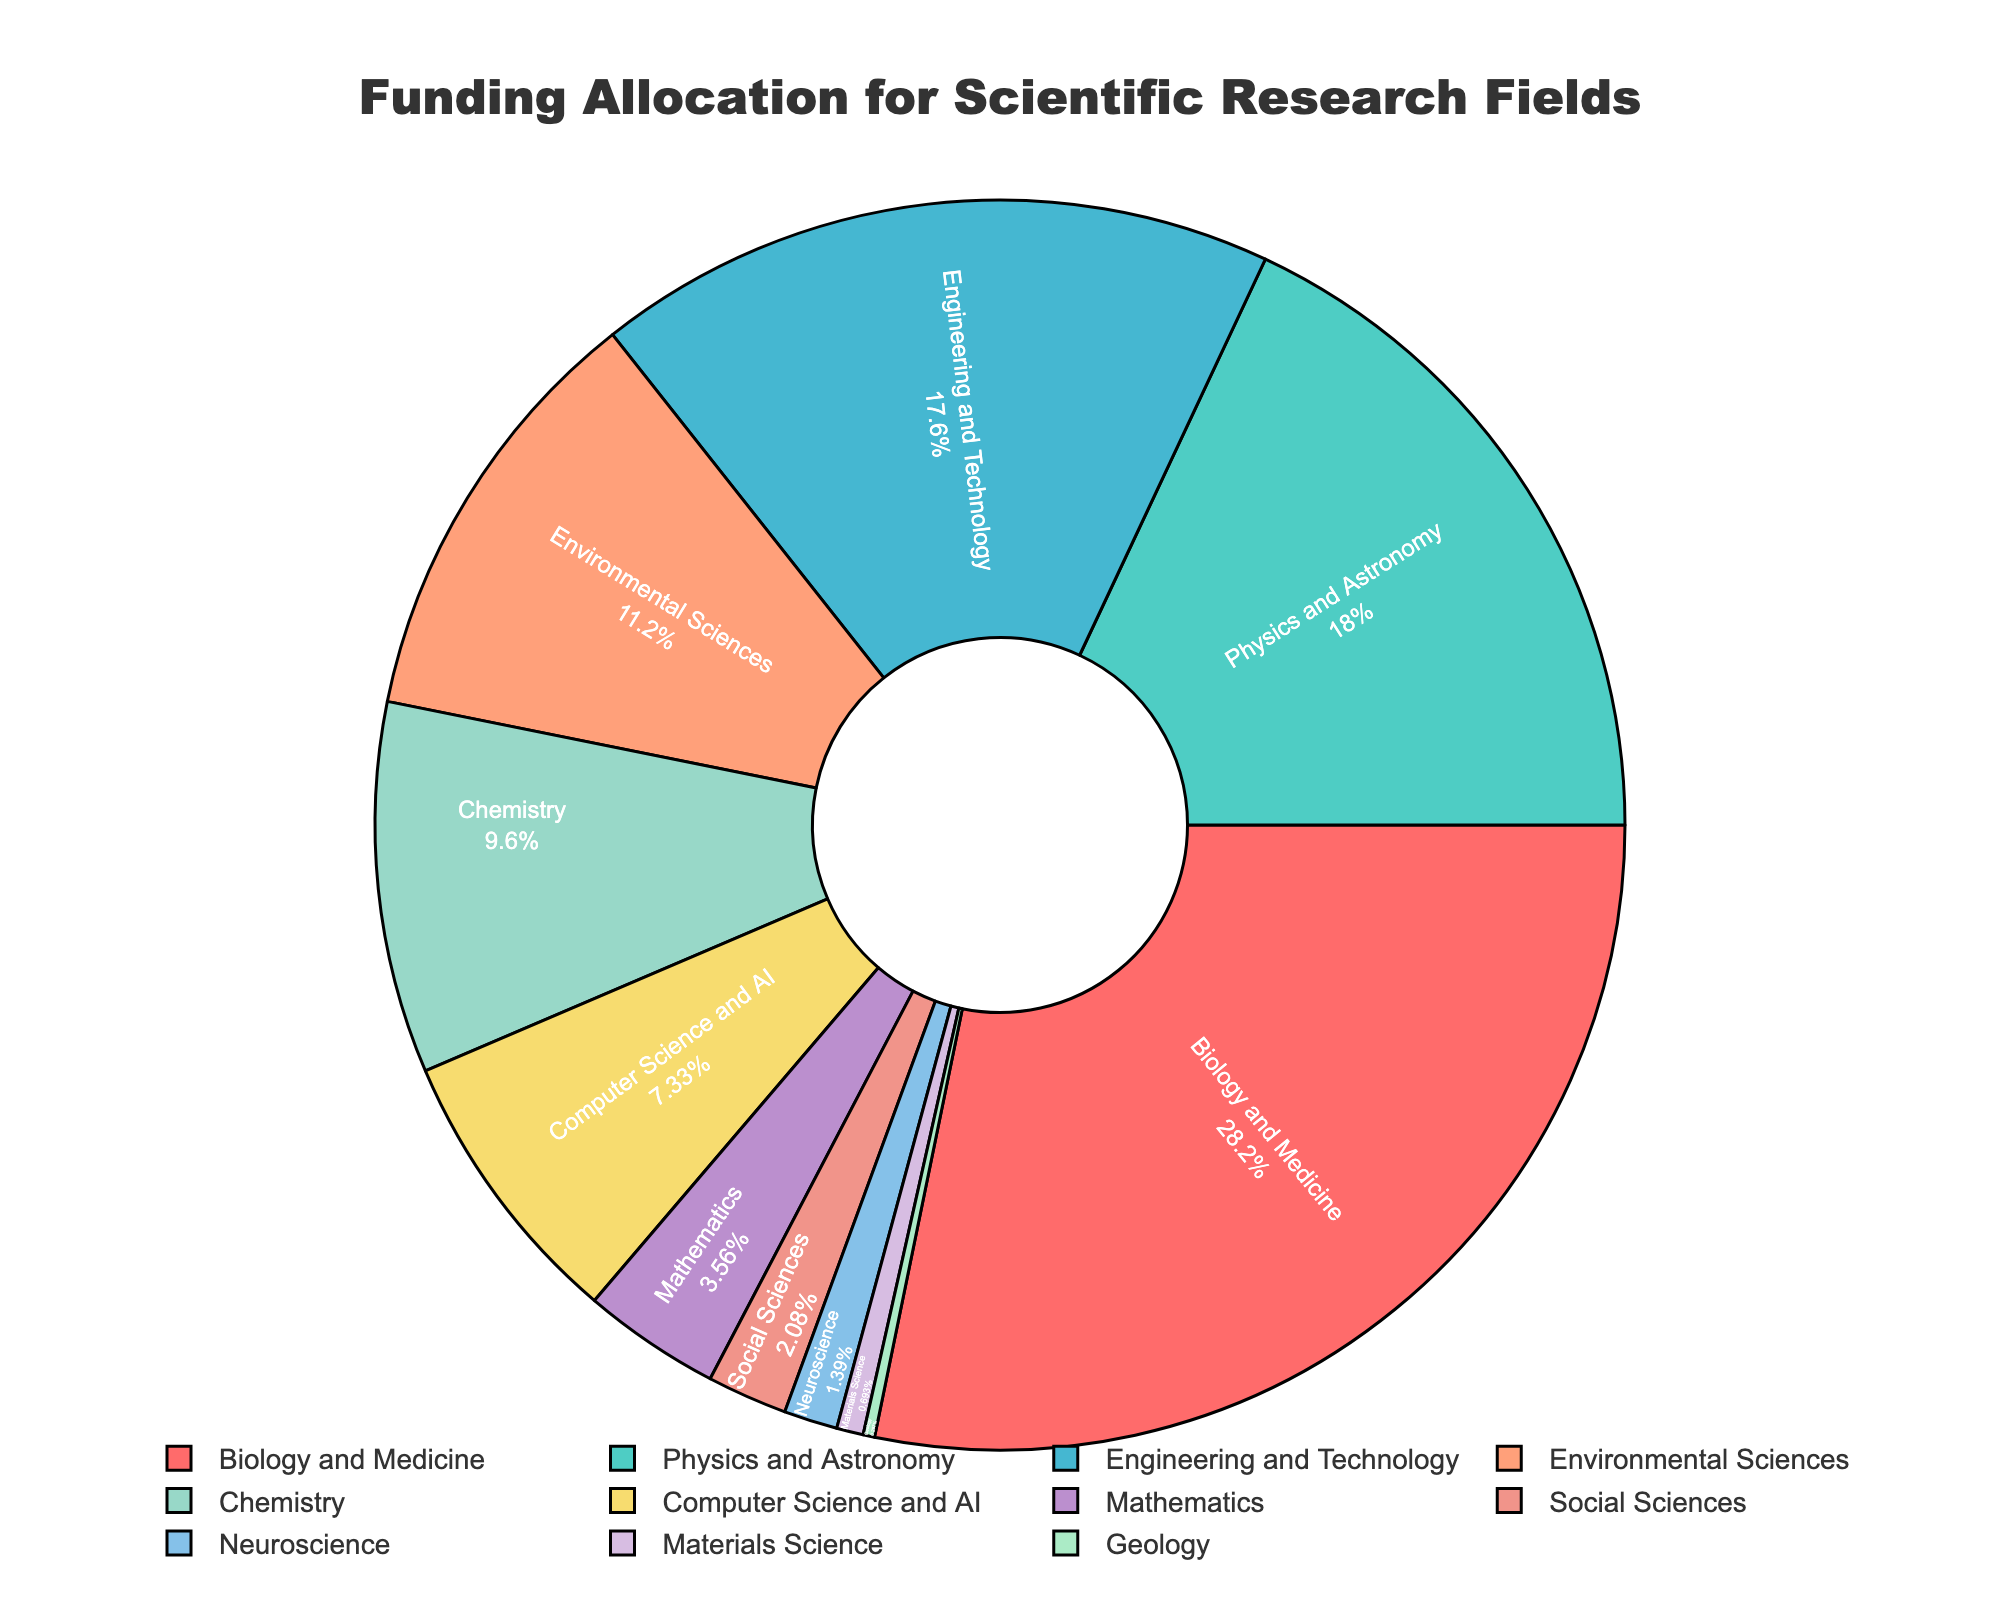Which field has the highest funding allocation? According to the pie chart, the field with the largest segment and percentage is Biology and Medicine, which is labeled with a 28.5% allocation.
Answer: Biology and Medicine What is the combined funding percentage for Environmental Sciences and Chemistry? From the pie chart, Environmental Sciences is allocated 11.3% and Chemistry is allocated 9.7%. Their combined funding percentage is 11.3% + 9.7% = 21%.
Answer: 21% Compare the funding allocations between Physics and Astronomy, and Engineering and Technology. Which one is higher and by how much? Physics and Astronomy has a funding allocation of 18.2%, while Engineering and Technology has an allocation of 17.8%. Physics and Astronomy has a higher allocation by 18.2% - 17.8% = 0.4%.
Answer: Physics and Astronomy by 0.4% What's the total funding percentage allocated to fields with less than 5% funding each? Fields with less than 5% funding are Mathematics (3.6%), Social Sciences (2.1%), Neuroscience (1.4%), Materials Science (0.7%), and Geology (0.3%). Their total funding is 3.6% + 2.1% + 1.4% + 0.7% + 0.3% = 8.1%.
Answer: 8.1% Given the provided colors, which field is represented by the blue-tinted segment? The pie chart likely uses distinguishable, contrasting colors for each field. By process of elimination and typical color associations, the field represented by the blue-tinted segment is Physics and Astronomy.
Answer: Physics and Astronomy What is the difference in funding allocation between the highest and the lowest funded fields? The highest funded field is Biology and Medicine with 28.5%, and the lowest funded field is Geology with 0.3%. The difference is 28.5% - 0.3% = 28.2%.
Answer: 28.2% If the funding for Computer Science and AI increased by 50%, what would its new percentage be? The current allocation for Computer Science and AI is 7.4%. A 50% increase would be calculated as 7.4% * 0.5 = 3.7%. Adding this to the original percentage: 7.4% + 3.7% = 11.1%.
Answer: 11.1% Identify the fields that are funded closer to the median percentage of all allocations. To find the median, we need to list all percentages in ascending order: 0.3%, 0.7%, 1.4%, 2.1%, 3.6%, 7.4%, 9.7%, 11.3%, 17.8%, 18.2%, 28.5%. The 6th value, which is the median, is 7.4%. The fields closer to this median value are Chemistry (9.7%) and Environmental Sciences (11.3%).
Answer: Chemistry and Environmental Sciences Which three fields follow Biology and Medicine in terms of funding allocation? Following Biology and Medicine (28.5%) are Physics and Astronomy (18.2%), Engineering and Technology (17.8%), and Environmental Sciences (11.3%).
Answer: Physics and Astronomy, Engineering and Technology, Environmental Sciences 